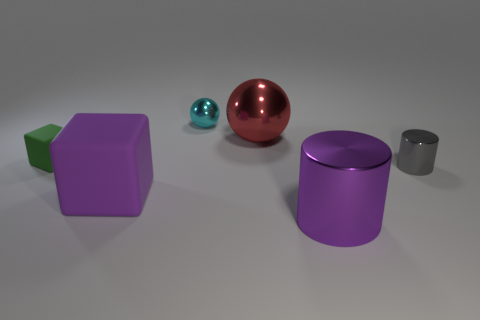Add 3 big red balls. How many objects exist? 9 Subtract all green cubes. How many cubes are left? 1 Subtract all balls. How many objects are left? 4 Subtract 0 red blocks. How many objects are left? 6 Subtract all gray blocks. Subtract all cyan spheres. How many blocks are left? 2 Subtract all cyan balls. Subtract all small green rubber cubes. How many objects are left? 4 Add 4 purple shiny things. How many purple shiny things are left? 5 Add 3 big cylinders. How many big cylinders exist? 4 